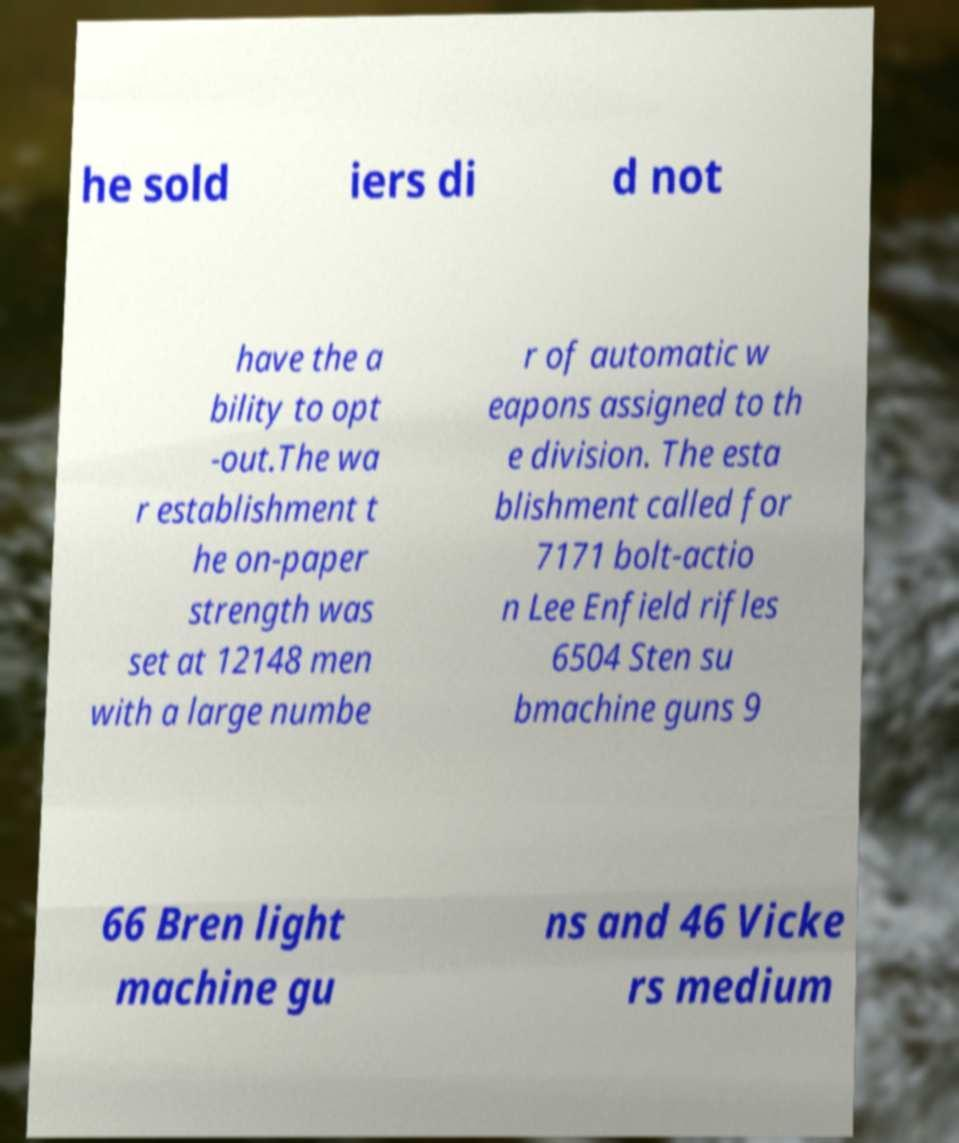For documentation purposes, I need the text within this image transcribed. Could you provide that? he sold iers di d not have the a bility to opt -out.The wa r establishment t he on-paper strength was set at 12148 men with a large numbe r of automatic w eapons assigned to th e division. The esta blishment called for 7171 bolt-actio n Lee Enfield rifles 6504 Sten su bmachine guns 9 66 Bren light machine gu ns and 46 Vicke rs medium 